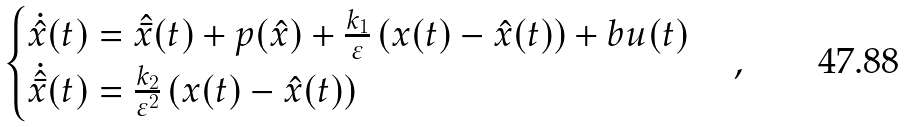<formula> <loc_0><loc_0><loc_500><loc_500>\begin{cases} \dot { \hat { x } } ( t ) = \hat { \bar { x } } ( t ) + p ( \hat { x } ) + { \frac { k _ { 1 } } { \varepsilon } } \left ( { x ( t ) - \hat { x } ( t ) } \right ) + b u ( t ) \\ \dot { \hat { \bar { x } } } ( t ) = { \frac { k _ { 2 } } { \varepsilon ^ { 2 } } } \left ( { x ( t ) - \hat { x } ( t ) } \right ) \end{cases} ,</formula> 